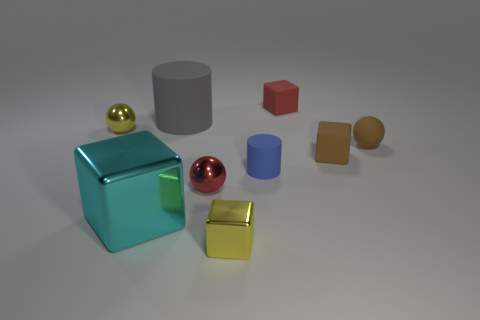There is a small thing that is the same color as the small matte sphere; what is its material?
Offer a very short reply. Rubber. What is the size of the rubber thing that is the same color as the tiny rubber sphere?
Make the answer very short. Small. How many yellow balls are the same size as the gray object?
Ensure brevity in your answer.  0. Are there more small blocks that are behind the brown block than tiny brown objects that are on the left side of the red shiny object?
Give a very brief answer. Yes. What is the color of the tiny metal ball in front of the cylinder that is on the right side of the big gray matte object?
Your response must be concise. Red. Does the tiny yellow sphere have the same material as the tiny yellow block?
Give a very brief answer. Yes. Are there any brown objects of the same shape as the big gray matte thing?
Provide a short and direct response. No. Do the tiny matte block behind the tiny brown ball and the big metal object have the same color?
Your answer should be compact. No. Does the red thing that is behind the gray matte cylinder have the same size as the yellow object that is behind the large metallic cube?
Give a very brief answer. Yes. What size is the gray object that is made of the same material as the small cylinder?
Provide a succinct answer. Large. 